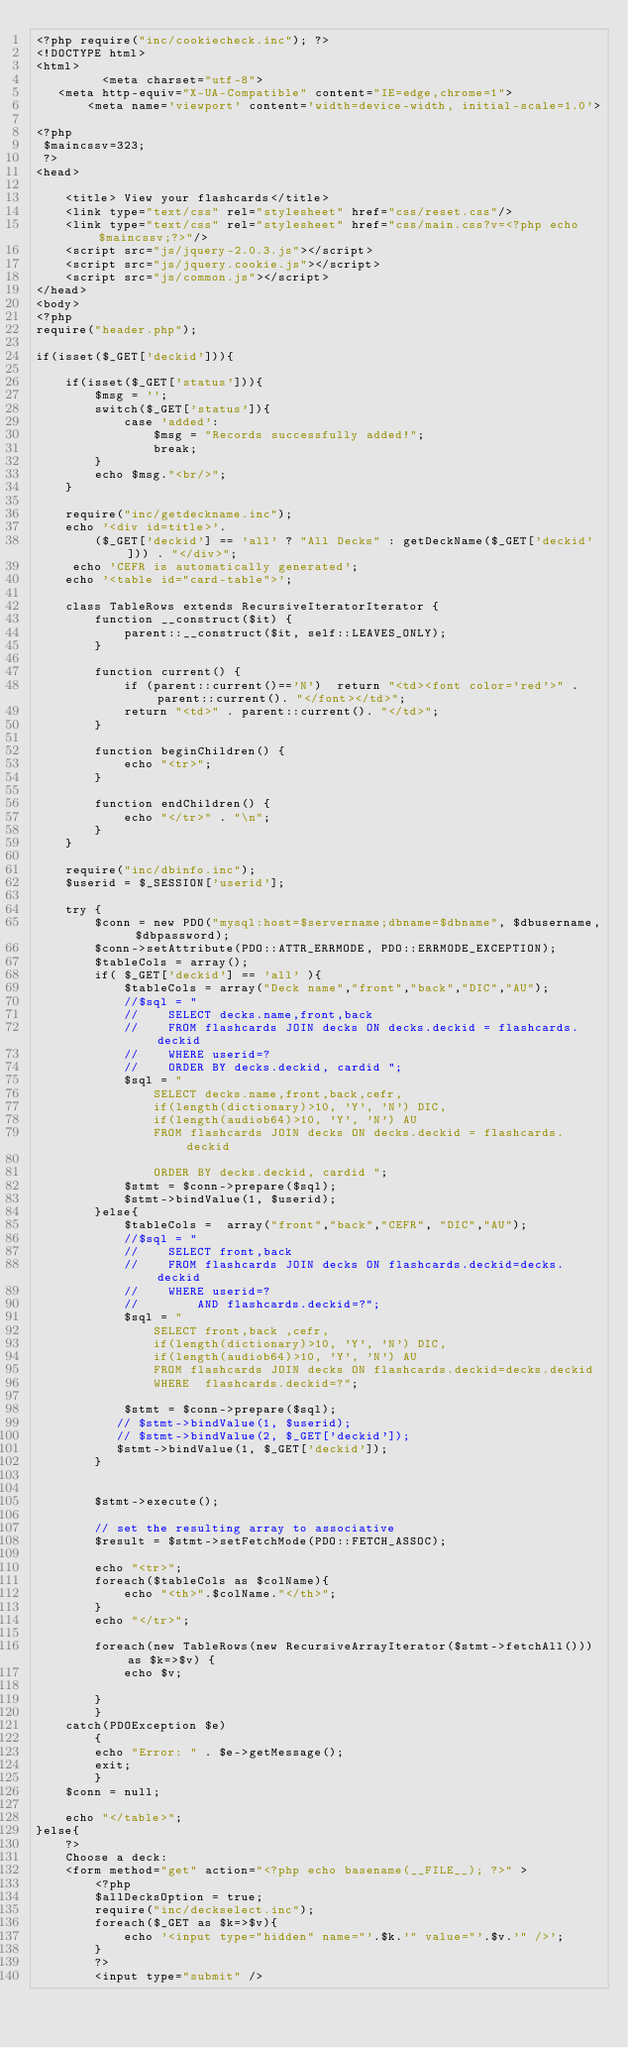<code> <loc_0><loc_0><loc_500><loc_500><_PHP_><?php require("inc/cookiecheck.inc"); ?>
<!DOCTYPE html>
<html>
	     <meta charset="utf-8">
   <meta http-equiv="X-UA-Compatible" content="IE=edge,chrome=1">
       <meta name='viewport' content='width=device-width, initial-scale=1.0'>
	
<?php
 $maincssv=323;
 ?>
<head>

    <title> View your flashcards</title>
    <link type="text/css" rel="stylesheet" href="css/reset.css"/>
    <link type="text/css" rel="stylesheet" href="css/main.css?v=<?php echo $maincssv;?>"/>
    <script src="js/jquery-2.0.3.js"></script>
    <script src="js/jquery.cookie.js"></script>
    <script src="js/common.js"></script>
</head>
<body>
<?php
require("header.php");

if(isset($_GET['deckid'])){

    if(isset($_GET['status'])){
        $msg = '';
        switch($_GET['status']){
            case 'added':
                $msg = "Records successfully added!";
                break;
        }
        echo $msg."<br/>";
    }

    require("inc/getdeckname.inc");
    echo '<div id=title>'.
        ($_GET['deckid'] == 'all' ? "All Decks" : getDeckName($_GET['deckid'])) . "</div>";
     echo 'CEFR is automatically generated';
    echo '<table id="card-table">';
    
    class TableRows extends RecursiveIteratorIterator { 
        function __construct($it) { 
            parent::__construct($it, self::LEAVES_ONLY); 
        }
    
        function current() {
        	if (parent::current()=='N')  return "<td><font color='red'>" . parent::current(). "</font></td>";
            return "<td>" . parent::current(). "</td>";
        }
    
        function beginChildren() { 
            echo "<tr>"; 
        } 
    
        function endChildren() { 
            echo "</tr>" . "\n";
        } 
    } 
   
    require("inc/dbinfo.inc");
    $userid = $_SESSION['userid'];
    
    try {
        $conn = new PDO("mysql:host=$servername;dbname=$dbname", $dbusername, $dbpassword);
        $conn->setAttribute(PDO::ATTR_ERRMODE, PDO::ERRMODE_EXCEPTION);
        $tableCols = array();
        if( $_GET['deckid'] == 'all' ){
            $tableCols = array("Deck name","front","back","DIC","AU");
            //$sql = "
            //    SELECT decks.name,front,back 
            //    FROM flashcards JOIN decks ON decks.deckid = flashcards.deckid
            //    WHERE userid=?
            //    ORDER BY decks.deckid, cardid ";
            $sql = "
                SELECT decks.name,front,back,cefr, 
                if(length(dictionary)>10, 'Y', 'N') DIC,
                if(length(audiob64)>10, 'Y', 'N') AU
                FROM flashcards JOIN decks ON decks.deckid = flashcards.deckid
                
                ORDER BY decks.deckid, cardid ";    
            $stmt = $conn->prepare($sql); 
            $stmt->bindValue(1, $userid);
        }else{
            $tableCols =  array("front","back","CEFR", "DIC","AU");
            //$sql = "
            //    SELECT front,back 
            //    FROM flashcards JOIN decks ON flashcards.deckid=decks.deckid 
            //    WHERE userid=? 
            //        AND flashcards.deckid=?";
            $sql = "
                SELECT front,back ,cefr,
                if(length(dictionary)>10, 'Y', 'N') DIC,
                if(length(audiob64)>10, 'Y', 'N') AU
                FROM flashcards JOIN decks ON flashcards.deckid=decks.deckid 
                WHERE  flashcards.deckid=?";

            $stmt = $conn->prepare($sql); 
           // $stmt->bindValue(1, $userid);
           // $stmt->bindValue(2, $_GET['deckid']);
           $stmt->bindValue(1, $_GET['deckid']);
        }

        
        $stmt->execute();
    
        // set the resulting array to associative
        $result = $stmt->setFetchMode(PDO::FETCH_ASSOC); 
    
        echo "<tr>";
        foreach($tableCols as $colName){
            echo "<th>".$colName."</th>";
        }
        echo "</tr>";
        
        foreach(new TableRows(new RecursiveArrayIterator($stmt->fetchAll())) as $k=>$v) { 
            echo $v;
            
        }
        }
    catch(PDOException $e)
        {
        echo "Error: " . $e->getMessage();
        exit;
        }
    $conn = null;
    
    echo "</table>";
}else{
    ?>
    Choose a deck:
    <form method="get" action="<?php echo basename(__FILE__); ?>" >
        <?php 
        $allDecksOption = true;
        require("inc/deckselect.inc"); 
        foreach($_GET as $k=>$v){
            echo '<input type="hidden" name="'.$k.'" value="'.$v.'" />';
        }
        ?>
        <input type="submit" /></code> 